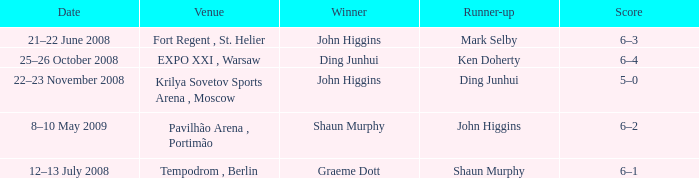Who was the winner in the match that had John Higgins as runner-up? Shaun Murphy. Can you parse all the data within this table? {'header': ['Date', 'Venue', 'Winner', 'Runner-up', 'Score'], 'rows': [['21–22 June 2008', 'Fort Regent , St. Helier', 'John Higgins', 'Mark Selby', '6–3'], ['25–26 October 2008', 'EXPO XXI , Warsaw', 'Ding Junhui', 'Ken Doherty', '6–4'], ['22–23 November 2008', 'Krilya Sovetov Sports Arena , Moscow', 'John Higgins', 'Ding Junhui', '5–0'], ['8–10 May 2009', 'Pavilhão Arena , Portimão', 'Shaun Murphy', 'John Higgins', '6–2'], ['12–13 July 2008', 'Tempodrom , Berlin', 'Graeme Dott', 'Shaun Murphy', '6–1']]} 